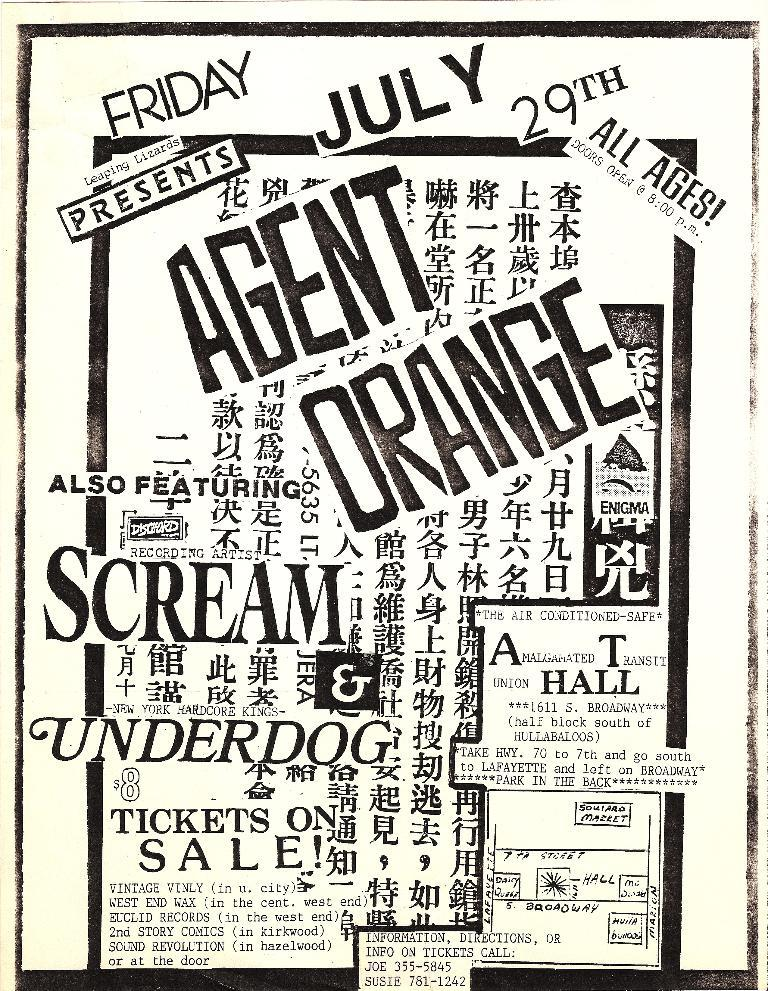<image>
Render a clear and concise summary of the photo. An advertisement for agent orange on July 29th shows words in black and white. 